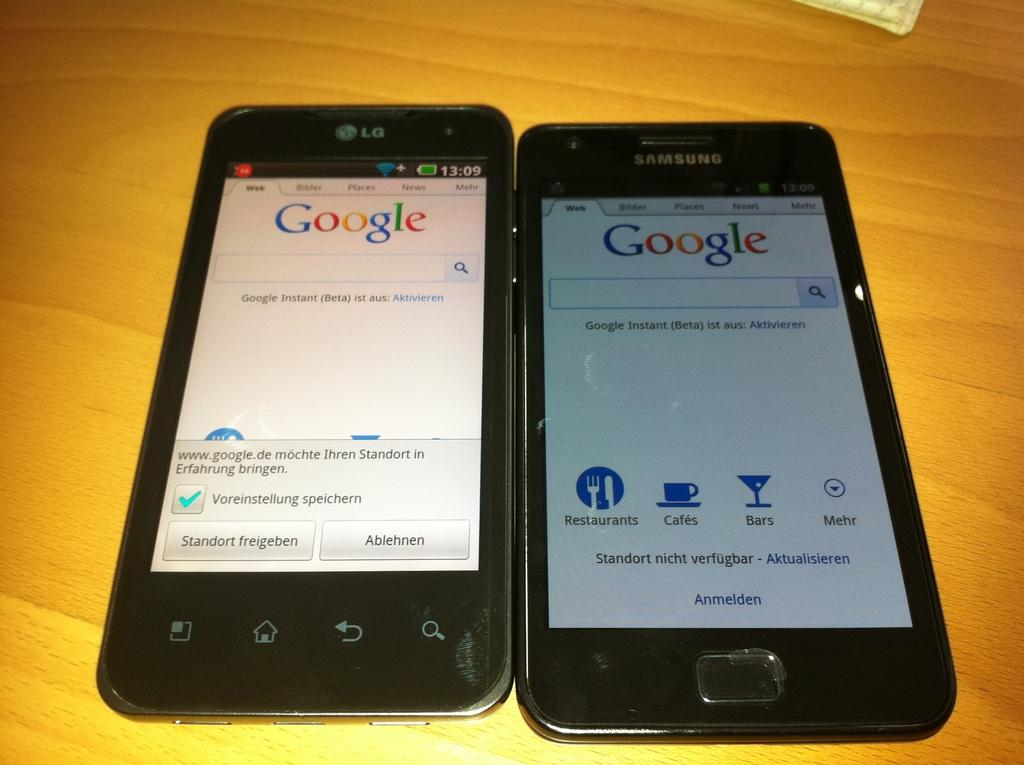<image>
Provide a brief description of the given image. A LG and Samsung cell phones sit side by side with Google on the screens. 